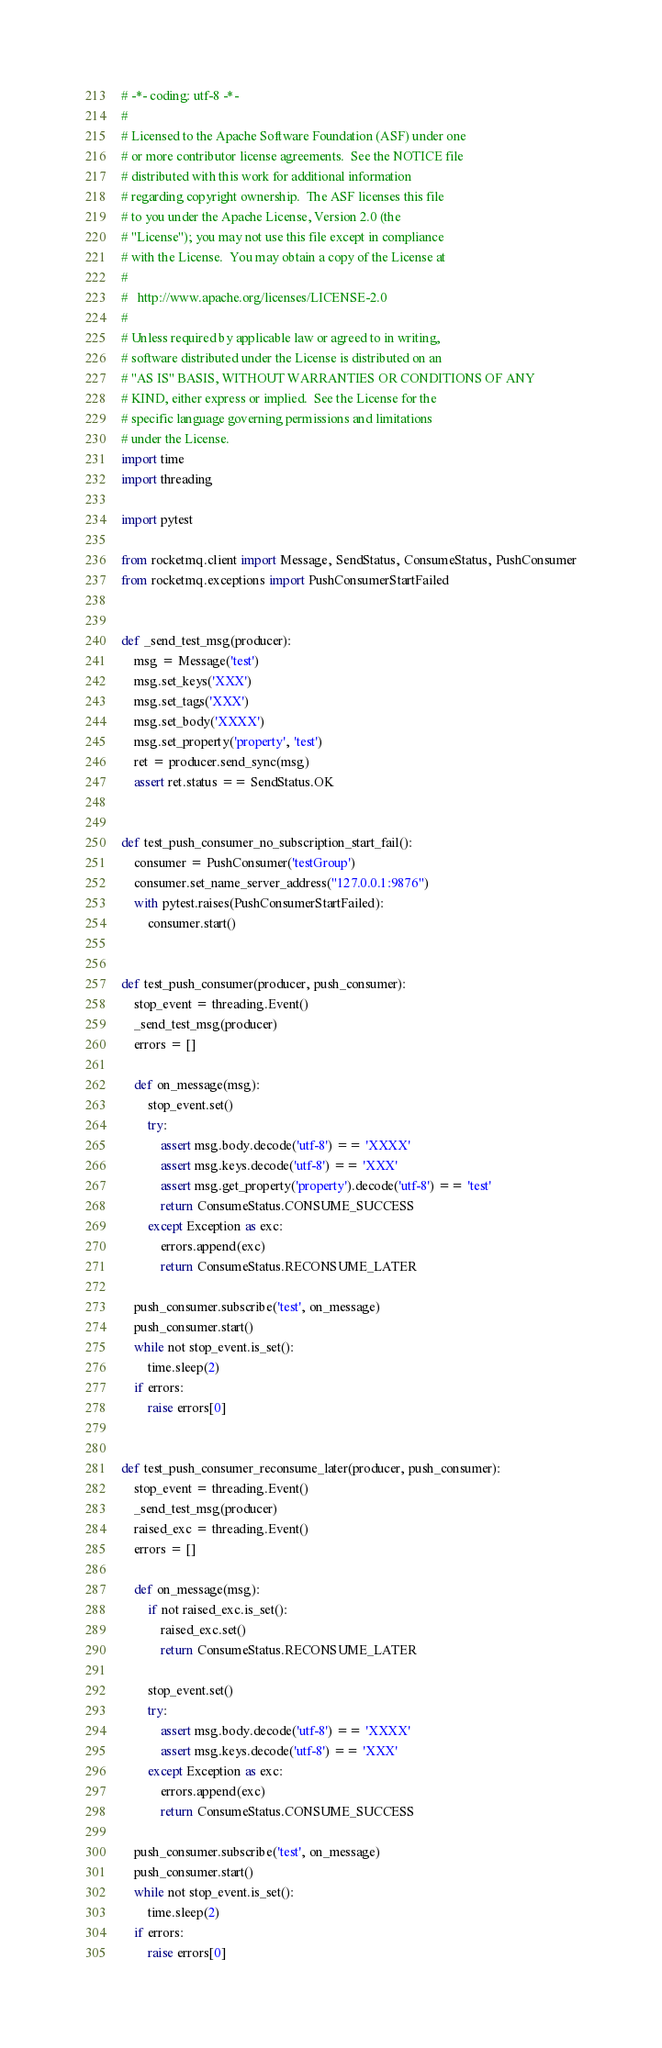Convert code to text. <code><loc_0><loc_0><loc_500><loc_500><_Python_># -*- coding: utf-8 -*-
#
# Licensed to the Apache Software Foundation (ASF) under one
# or more contributor license agreements.  See the NOTICE file
# distributed with this work for additional information
# regarding copyright ownership.  The ASF licenses this file
# to you under the Apache License, Version 2.0 (the
# "License"); you may not use this file except in compliance
# with the License.  You may obtain a copy of the License at
#
#   http://www.apache.org/licenses/LICENSE-2.0
#
# Unless required by applicable law or agreed to in writing,
# software distributed under the License is distributed on an
# "AS IS" BASIS, WITHOUT WARRANTIES OR CONDITIONS OF ANY
# KIND, either express or implied.  See the License for the
# specific language governing permissions and limitations
# under the License.
import time
import threading

import pytest

from rocketmq.client import Message, SendStatus, ConsumeStatus, PushConsumer
from rocketmq.exceptions import PushConsumerStartFailed


def _send_test_msg(producer):
    msg = Message('test')
    msg.set_keys('XXX')
    msg.set_tags('XXX')
    msg.set_body('XXXX')
    msg.set_property('property', 'test')
    ret = producer.send_sync(msg)
    assert ret.status == SendStatus.OK


def test_push_consumer_no_subscription_start_fail():
    consumer = PushConsumer('testGroup')
    consumer.set_name_server_address("127.0.0.1:9876")
    with pytest.raises(PushConsumerStartFailed):
        consumer.start()


def test_push_consumer(producer, push_consumer):
    stop_event = threading.Event()
    _send_test_msg(producer)
    errors = []

    def on_message(msg):
        stop_event.set()
        try:
            assert msg.body.decode('utf-8') == 'XXXX'
            assert msg.keys.decode('utf-8') == 'XXX'
            assert msg.get_property('property').decode('utf-8') == 'test'
            return ConsumeStatus.CONSUME_SUCCESS
        except Exception as exc:
            errors.append(exc)
            return ConsumeStatus.RECONSUME_LATER

    push_consumer.subscribe('test', on_message)
    push_consumer.start()
    while not stop_event.is_set():
        time.sleep(2)
    if errors:
        raise errors[0]


def test_push_consumer_reconsume_later(producer, push_consumer):
    stop_event = threading.Event()
    _send_test_msg(producer)
    raised_exc = threading.Event()
    errors = []

    def on_message(msg):
        if not raised_exc.is_set():
            raised_exc.set()
            return ConsumeStatus.RECONSUME_LATER

        stop_event.set()
        try:
            assert msg.body.decode('utf-8') == 'XXXX'
            assert msg.keys.decode('utf-8') == 'XXX'
        except Exception as exc:
            errors.append(exc)
            return ConsumeStatus.CONSUME_SUCCESS

    push_consumer.subscribe('test', on_message)
    push_consumer.start()
    while not stop_event.is_set():
        time.sleep(2)
    if errors:
        raise errors[0]
</code> 